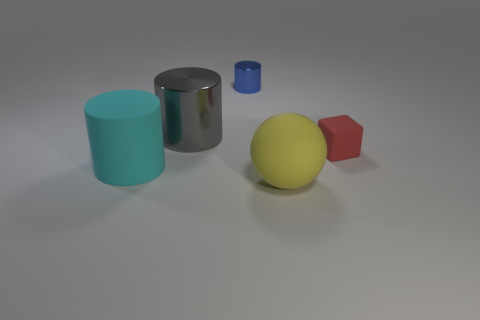How many other rubber cubes have the same color as the small cube?
Give a very brief answer. 0. What size is the thing that is in front of the big thing that is to the left of the big gray metallic cylinder?
Offer a terse response. Large. What is the shape of the tiny metallic thing?
Give a very brief answer. Cylinder. What is the material of the cylinder that is in front of the big metal cylinder?
Your answer should be very brief. Rubber. The rubber thing behind the rubber thing left of the object in front of the big cyan rubber cylinder is what color?
Keep it short and to the point. Red. There is a matte object that is the same size as the yellow matte ball; what is its color?
Provide a succinct answer. Cyan. How many rubber objects are either purple cubes or blue cylinders?
Give a very brief answer. 0. What is the color of the large ball that is the same material as the tiny red cube?
Your answer should be very brief. Yellow. There is a large cylinder behind the large matte thing that is behind the large sphere; what is it made of?
Give a very brief answer. Metal. How many objects are tiny objects that are on the left side of the tiny red rubber block or big matte things in front of the large cyan cylinder?
Offer a very short reply. 2. 